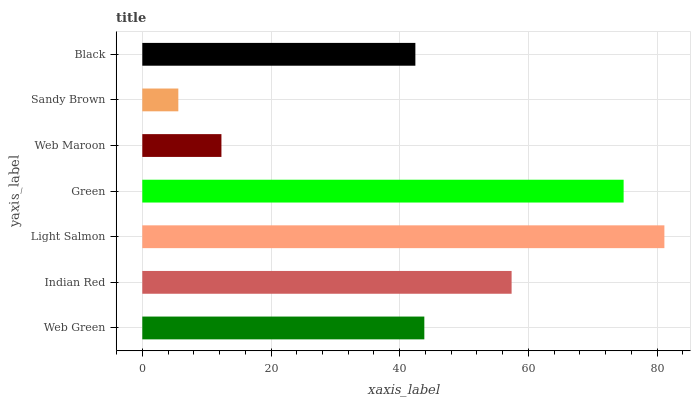Is Sandy Brown the minimum?
Answer yes or no. Yes. Is Light Salmon the maximum?
Answer yes or no. Yes. Is Indian Red the minimum?
Answer yes or no. No. Is Indian Red the maximum?
Answer yes or no. No. Is Indian Red greater than Web Green?
Answer yes or no. Yes. Is Web Green less than Indian Red?
Answer yes or no. Yes. Is Web Green greater than Indian Red?
Answer yes or no. No. Is Indian Red less than Web Green?
Answer yes or no. No. Is Web Green the high median?
Answer yes or no. Yes. Is Web Green the low median?
Answer yes or no. Yes. Is Green the high median?
Answer yes or no. No. Is Web Maroon the low median?
Answer yes or no. No. 